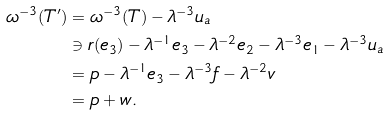Convert formula to latex. <formula><loc_0><loc_0><loc_500><loc_500>\omega ^ { - 3 } ( T ^ { \prime } ) & = \omega ^ { - 3 } ( T ) - \lambda ^ { - 3 } u _ { a } \\ & \ni r ( e _ { 3 } ) - \lambda ^ { - 1 } e _ { 3 } - \lambda ^ { - 2 } e _ { 2 } - \lambda ^ { - 3 } e _ { 1 } - \lambda ^ { - 3 } u _ { a } \\ & = p - \lambda ^ { - 1 } e _ { 3 } - \lambda ^ { - 3 } f - \lambda ^ { - 2 } v \\ & = p + w .</formula> 